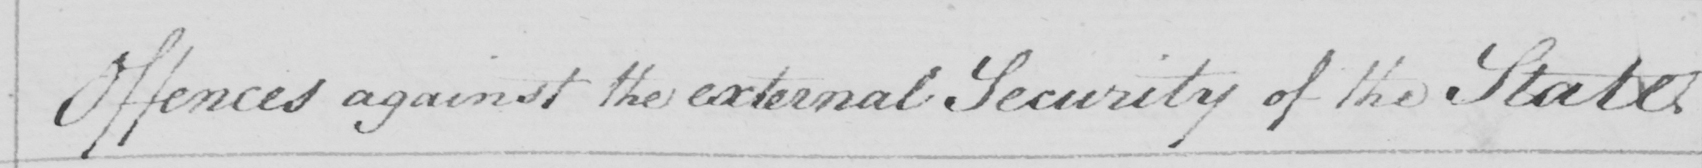What is written in this line of handwriting? Offences against the external Security of the State 